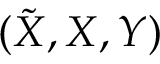Convert formula to latex. <formula><loc_0><loc_0><loc_500><loc_500>( \tilde { X } , X , Y )</formula> 